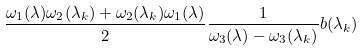Convert formula to latex. <formula><loc_0><loc_0><loc_500><loc_500>\frac { \omega _ { 1 } ( \lambda ) \omega _ { 2 } ( \lambda _ { k } ) + \omega _ { 2 } ( \lambda _ { k } ) \omega _ { 1 } ( \lambda ) } { 2 } \frac { 1 } { \omega _ { 3 } ( \lambda ) - \omega _ { 3 } ( \lambda _ { k } ) } b ( \lambda _ { k } )</formula> 